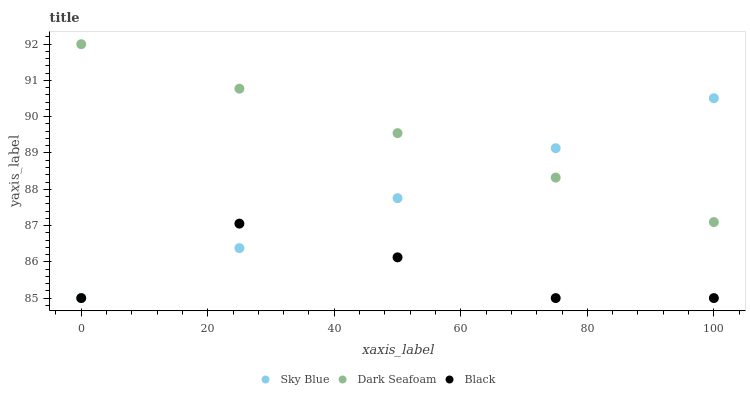Does Black have the minimum area under the curve?
Answer yes or no. Yes. Does Dark Seafoam have the maximum area under the curve?
Answer yes or no. Yes. Does Dark Seafoam have the minimum area under the curve?
Answer yes or no. No. Does Black have the maximum area under the curve?
Answer yes or no. No. Is Dark Seafoam the smoothest?
Answer yes or no. Yes. Is Black the roughest?
Answer yes or no. Yes. Is Black the smoothest?
Answer yes or no. No. Is Dark Seafoam the roughest?
Answer yes or no. No. Does Sky Blue have the lowest value?
Answer yes or no. Yes. Does Dark Seafoam have the lowest value?
Answer yes or no. No. Does Dark Seafoam have the highest value?
Answer yes or no. Yes. Does Black have the highest value?
Answer yes or no. No. Is Black less than Dark Seafoam?
Answer yes or no. Yes. Is Dark Seafoam greater than Black?
Answer yes or no. Yes. Does Sky Blue intersect Dark Seafoam?
Answer yes or no. Yes. Is Sky Blue less than Dark Seafoam?
Answer yes or no. No. Is Sky Blue greater than Dark Seafoam?
Answer yes or no. No. Does Black intersect Dark Seafoam?
Answer yes or no. No. 